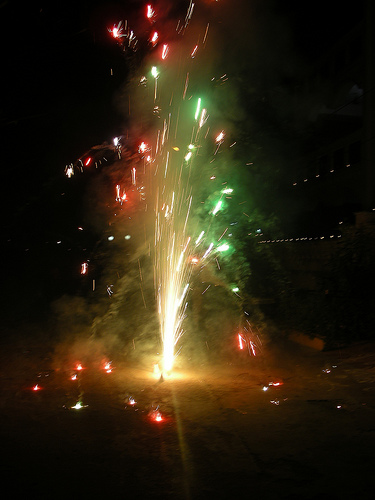<image>
Can you confirm if the sky is behind the light? Yes. From this viewpoint, the sky is positioned behind the light, with the light partially or fully occluding the sky. 